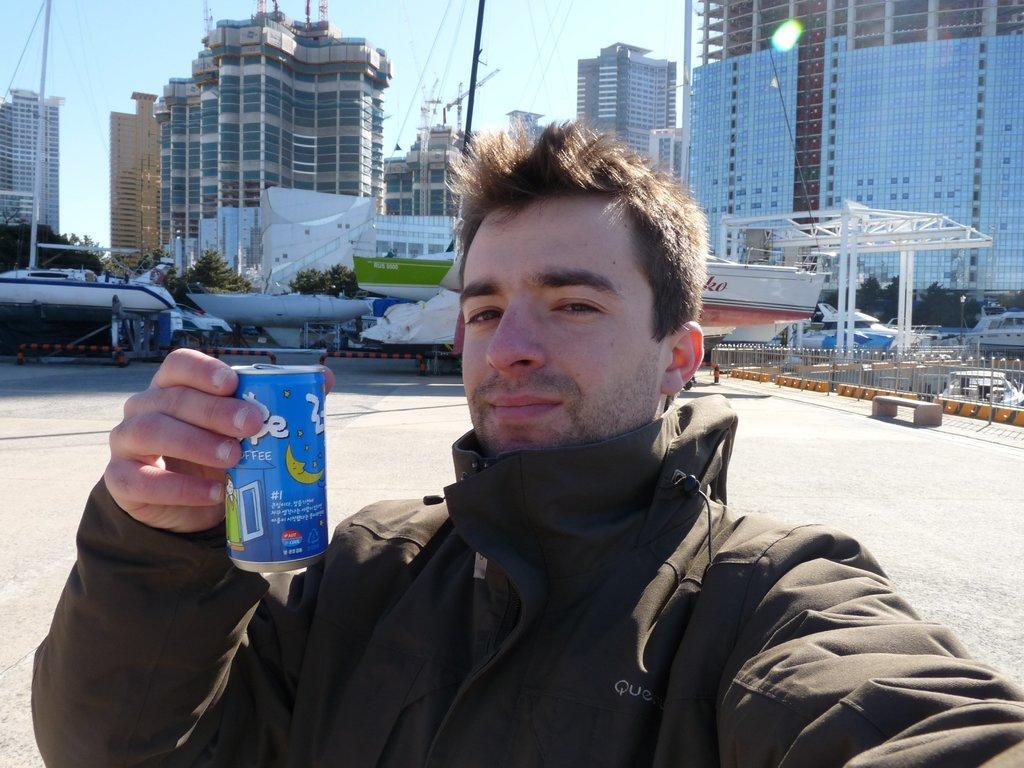Could you give a brief overview of what you see in this image? Here in this picture we can see a person present over a place and we can see he is wearing jacket and holding a tin in his hands and smiling and behind him we can see boats present near the shore and we can also see number of buildings also present and we can see the sky is clear. 